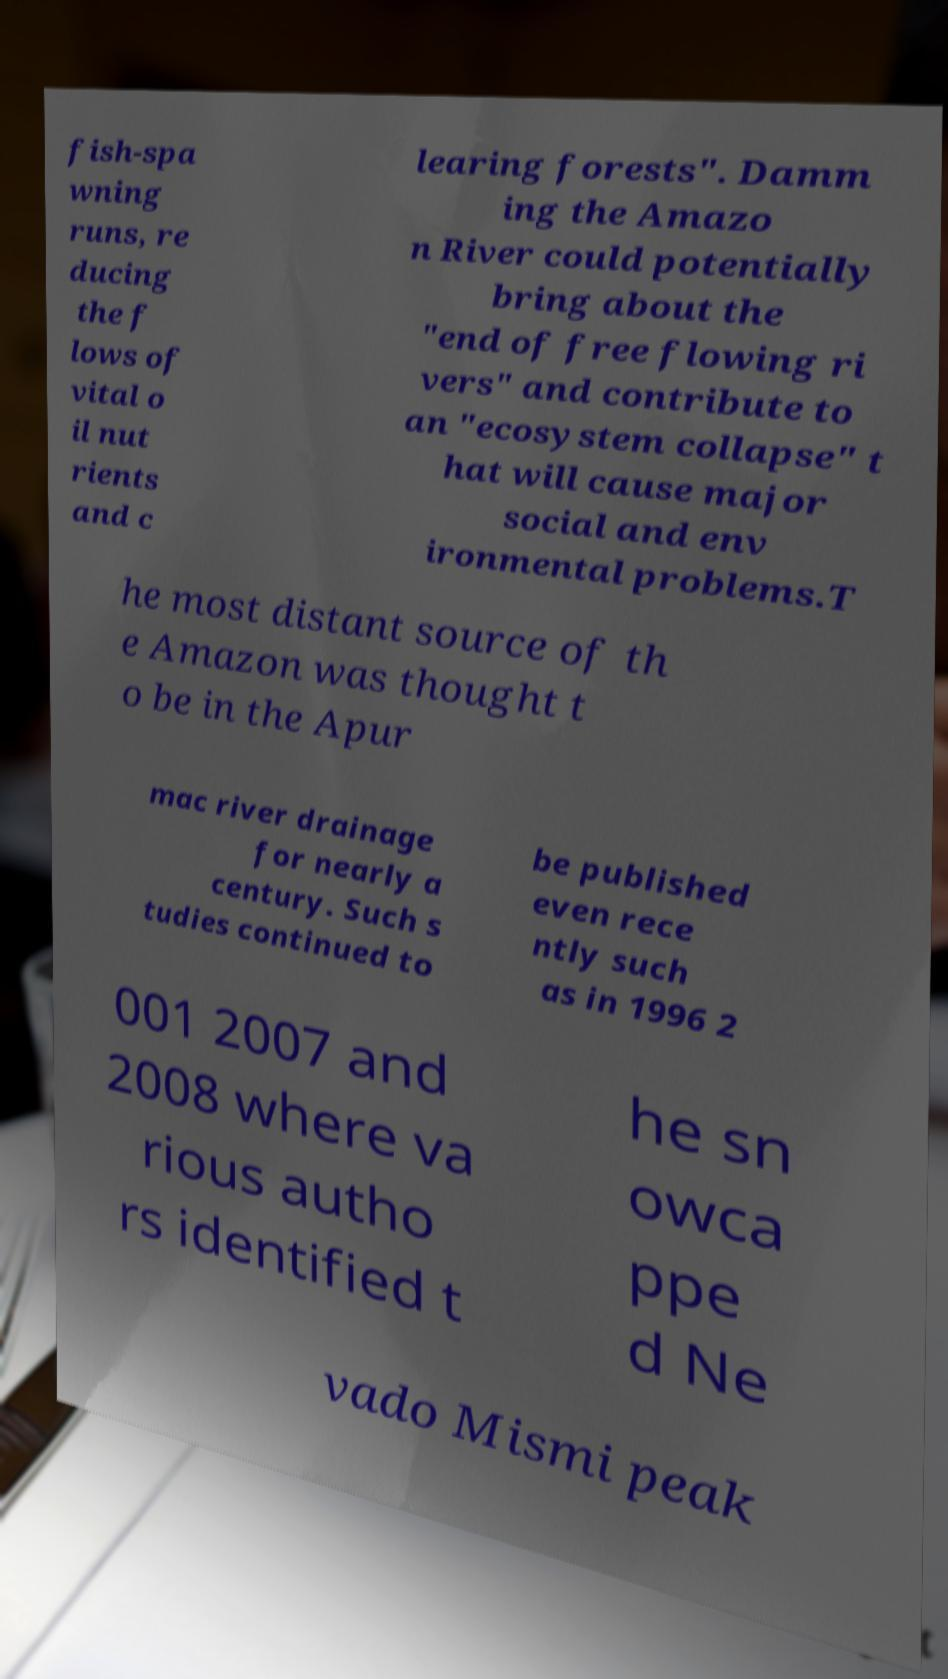Can you accurately transcribe the text from the provided image for me? fish-spa wning runs, re ducing the f lows of vital o il nut rients and c learing forests". Damm ing the Amazo n River could potentially bring about the "end of free flowing ri vers" and contribute to an "ecosystem collapse" t hat will cause major social and env ironmental problems.T he most distant source of th e Amazon was thought t o be in the Apur mac river drainage for nearly a century. Such s tudies continued to be published even rece ntly such as in 1996 2 001 2007 and 2008 where va rious autho rs identified t he sn owca ppe d Ne vado Mismi peak 